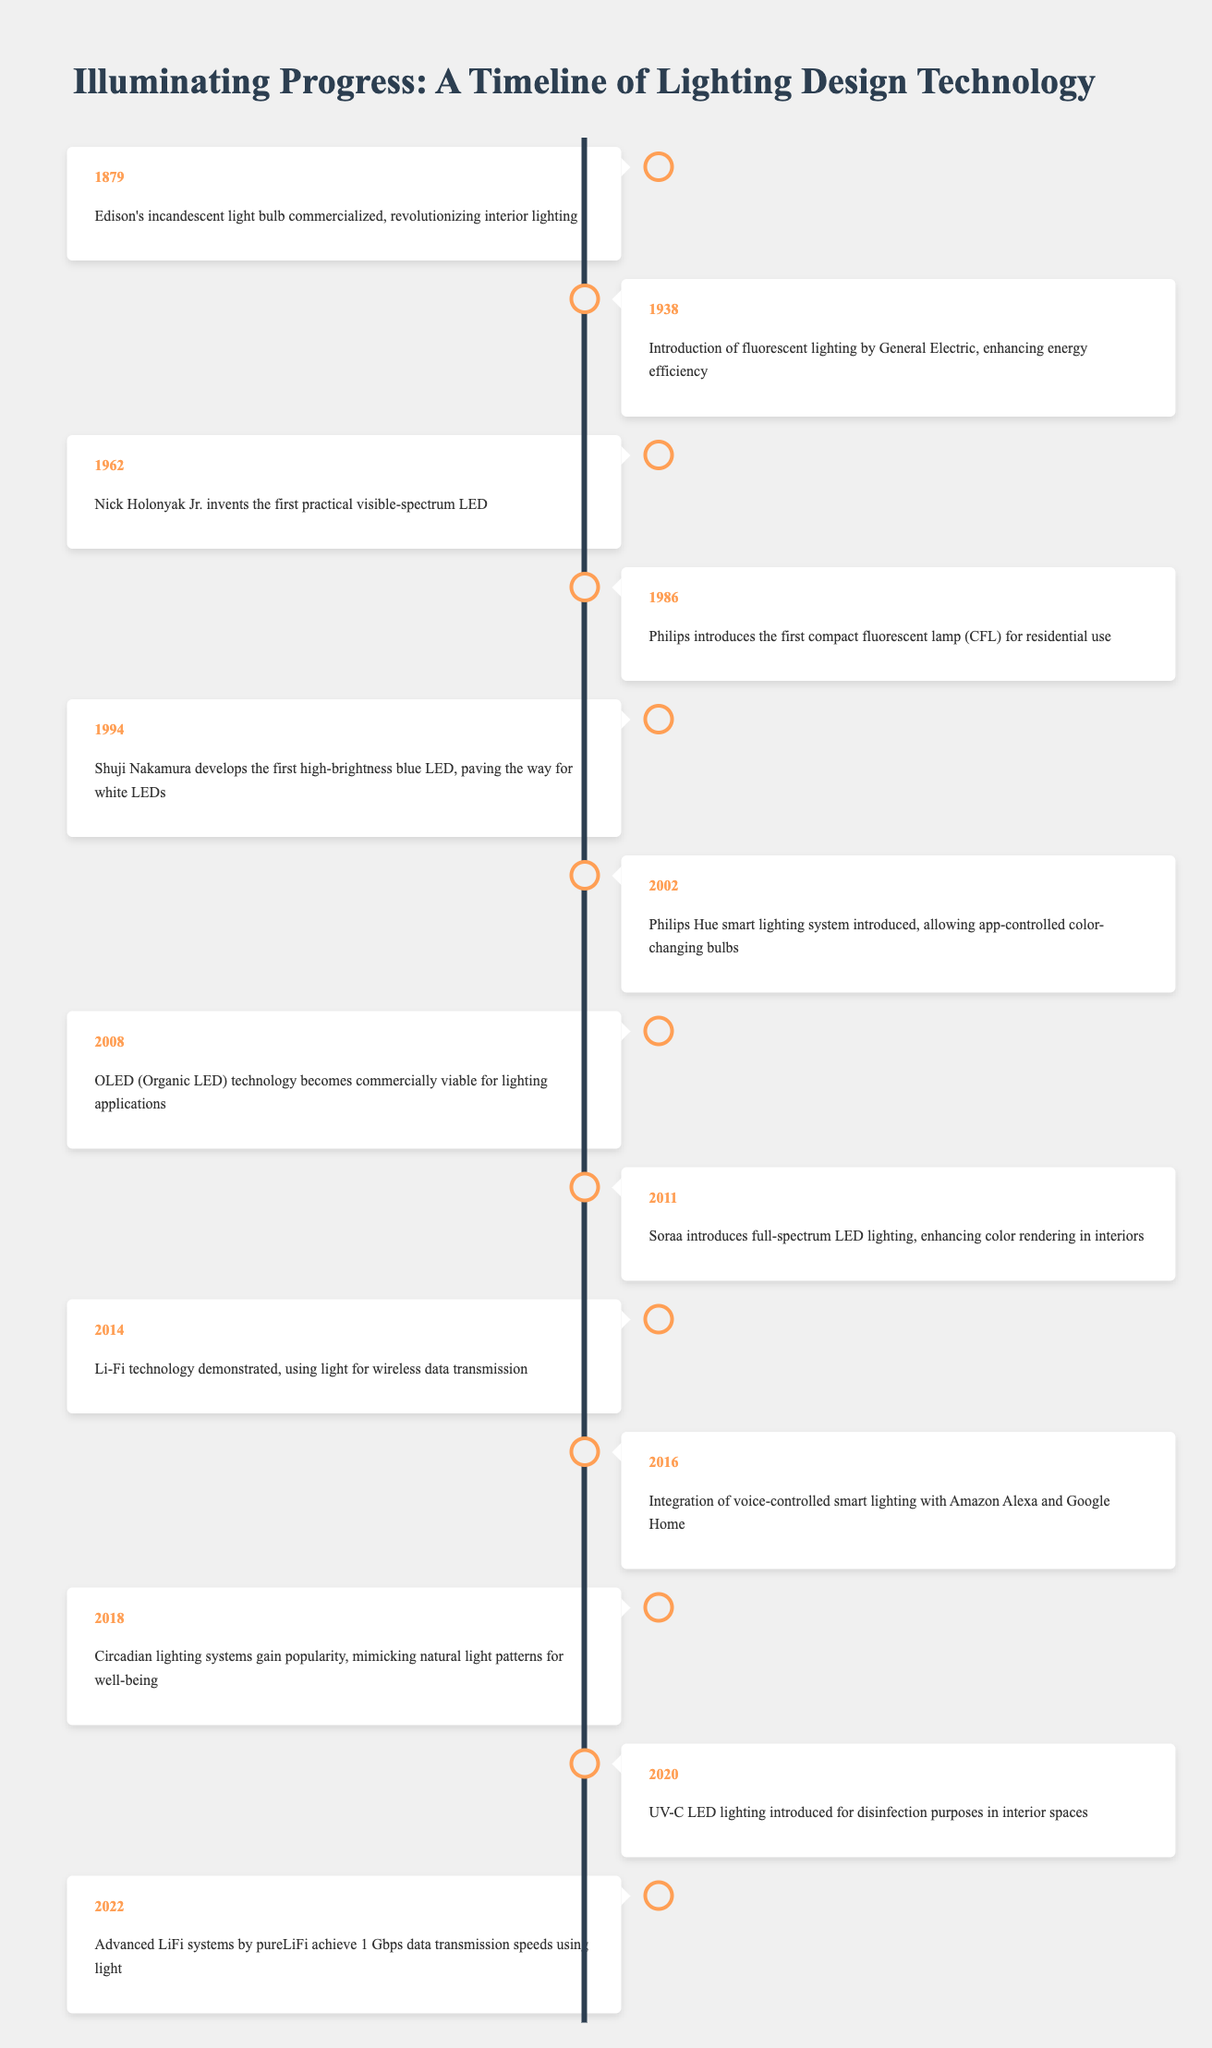What year was Edison's incandescent light bulb commercialized? According to the table, Edison's incandescent light bulb was commercialized in the year 1879.
Answer: 1879 Which event marked the introduction of fluorescent lighting? The table indicates that fluorescent lighting was introduced by General Electric in 1938.
Answer: Introduction of fluorescent lighting by General Electric What was the first practical LED invented and when? The table shows that the first practical visible-spectrum LED was invented by Nick Holonyak Jr. in 1962.
Answer: Nick Holonyak Jr. invented the first practical visible-spectrum LED in 1962 How many years passed between the introduction of compact fluorescent lamps and the development of high-brightness blue LEDs? The introduction of compact fluorescent lamps occurred in 1986 and the development of high-brightness blue LEDs happened in 1994. The difference in years is 1994 - 1986 = 8 years.
Answer: 8 years In which two years did substantial advancements in LED technology occur? The table lists the introduction of the first practical LED in 1962 and the development of the high-brightness blue LED in 1994 as significant milestones in LED technology advancements.
Answer: 1962 and 1994 Was the Philips Hue smart lighting system introduced before or after Li-Fi technology demonstration? The table shows that Philips Hue was introduced in 2002 and Li-Fi technology was demonstrated in 2014. Since 2002 is before 2014, the answer is before.
Answer: Before Which lighting technology was introduced first: OLED or full-spectrum LED lighting? According to the table, OLED technology was commercially viable in 2008, while full-spectrum LED lighting was introduced in 2011. Therefore, OLED technology was introduced first.
Answer: OLED technology was introduced first How does the adoption of circadian lighting relate to advancements in lighting technology? The table indicates that circadian lighting systems gained popularity in 2018, showing a trend towards integrating more natural light patterns into artificial lighting, which reflects a growing understanding of well-being in design.
Answer: A trend towards integrating natural light patterns in artificial lighting What is the significance of the 2020 introduction of UV-C LED lighting? The introduction of UV-C LED lighting in 2020 aimed at improving disinfection in interior spaces, highlighting the growing importance of health and safety in lighting design.
Answer: Improving disinfection in interior spaces What technological milestone occurred in 2022 related to Li-Fi? The table notes that in 2022, advanced Li-Fi systems achieved data transmission speeds of 1 Gbps using light, representing a significant milestone in wireless communication technology.
Answer: Advanced Li-Fi systems achieved 1 Gbps data transmission speeds 